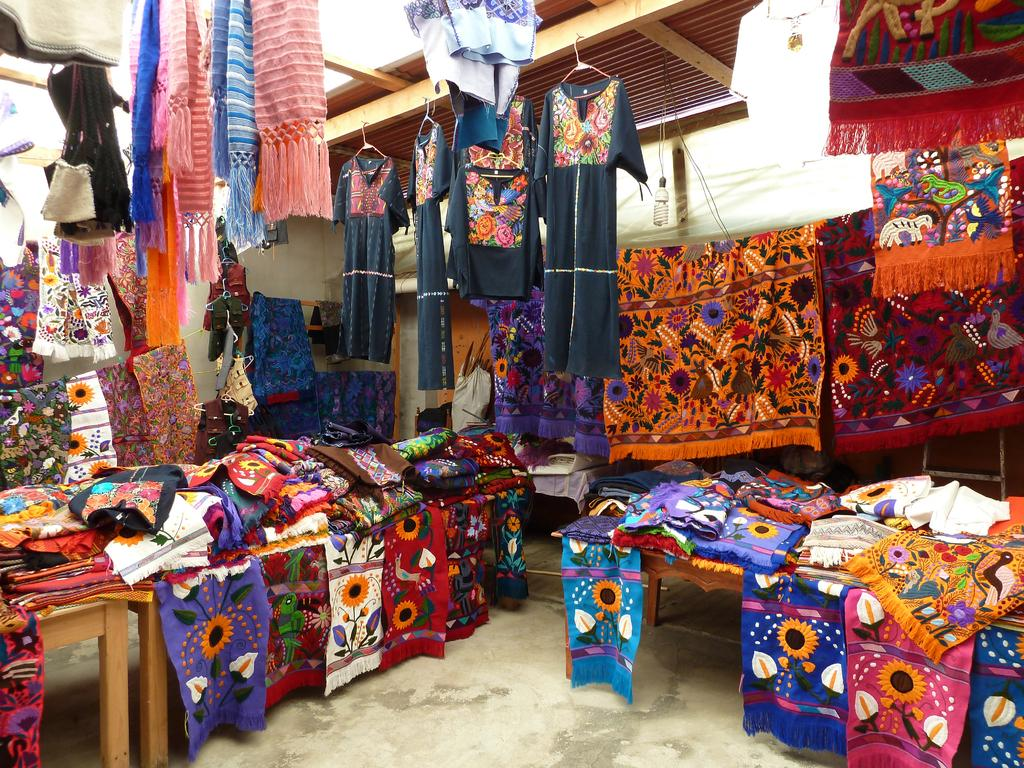What type of items can be seen in the image? There are clothes and tables in the image. Can you describe the clothes in the image? Unfortunately, the facts provided do not give specific details about the clothes. How many tables are visible in the image? The facts provided do not specify the number of tables in the image. What color is the eye of the shirt in the image? There is no shirt or eye present in the image. How does the measure of the table in the image compare to the size of the clothes? The facts provided do not give specific details about the size of the clothes or the table, so it is impossible to make a comparison. 